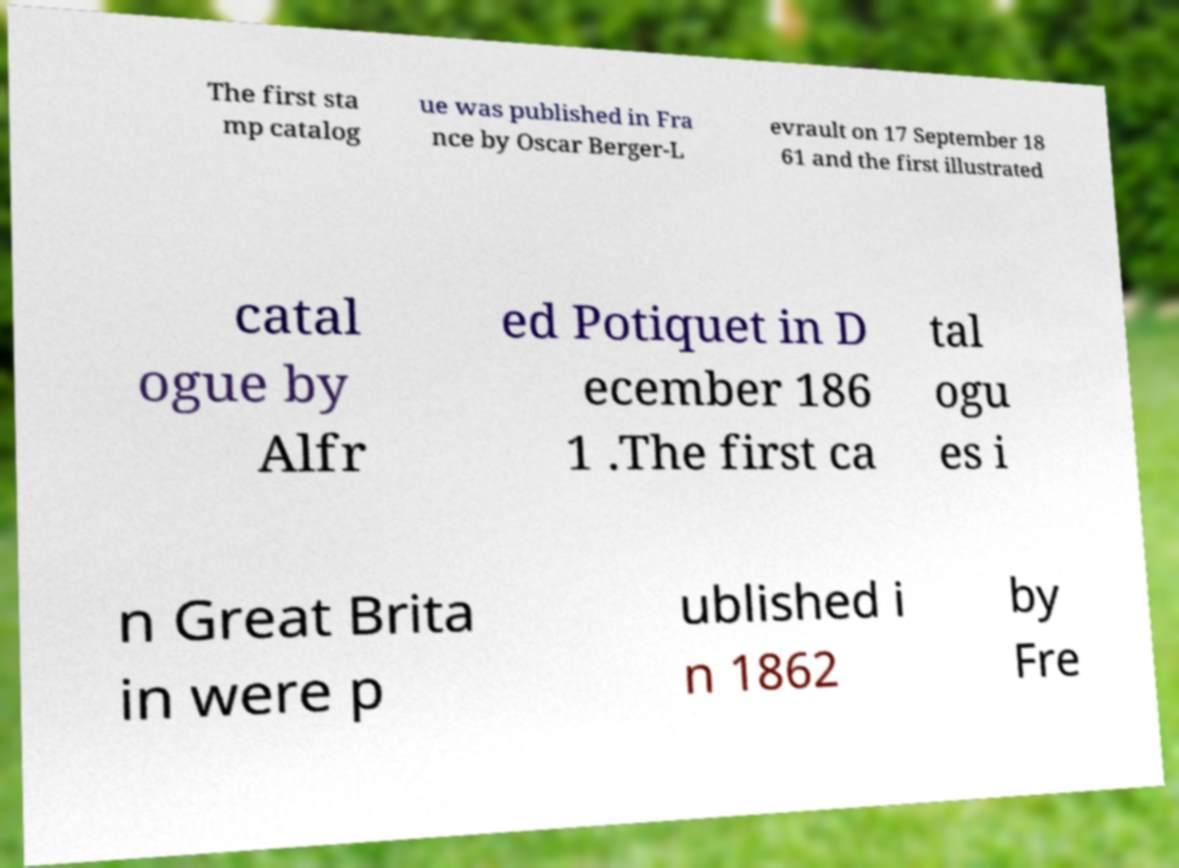I need the written content from this picture converted into text. Can you do that? The first sta mp catalog ue was published in Fra nce by Oscar Berger-L evrault on 17 September 18 61 and the first illustrated catal ogue by Alfr ed Potiquet in D ecember 186 1 .The first ca tal ogu es i n Great Brita in were p ublished i n 1862 by Fre 